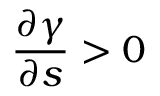Convert formula to latex. <formula><loc_0><loc_0><loc_500><loc_500>\frac { \partial \gamma } { \partial s } > 0</formula> 